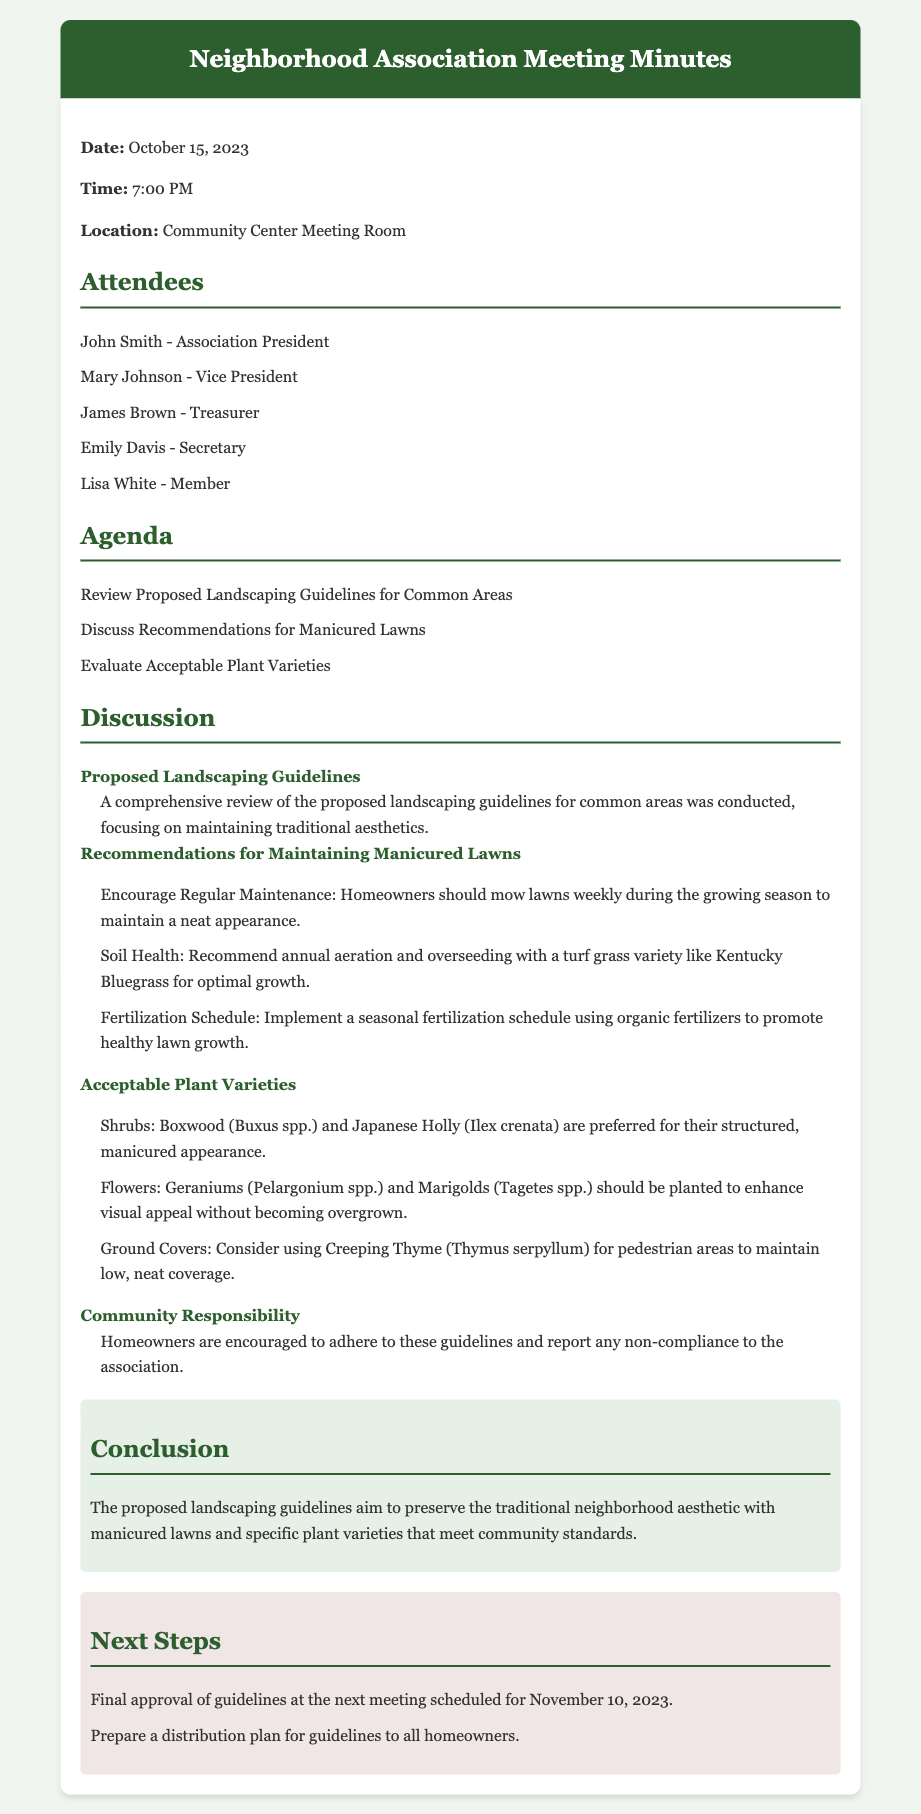What is the date of the meeting? The date of the meeting is explicitly stated in the document as October 15, 2023.
Answer: October 15, 2023 Who is the Vice President? The document lists the attendees, with Mary Johnson identified as the Vice President.
Answer: Mary Johnson What is one recommended action for maintaining lawns? The discussion section includes specific recommendations, one of which is to mow lawns weekly during the growing season.
Answer: Mow lawns weekly Which shrub variety is preferred? The acceptable plant varieties mention Boxwood as a preferred shrub for its manicured appearance.
Answer: Boxwood What will be discussed at the next meeting? The next meeting's agenda includes the final approval of the guidelines, which is explicitly mentioned in the next steps section.
Answer: Final approval of guidelines What type of fertilizer is recommended? The recommendations include implementing a seasonal fertilization schedule using organic fertilizers.
Answer: Organic fertilizers What is the location of the meeting? The document specifies the location where the meeting was held: Community Center Meeting Room.
Answer: Community Center Meeting Room What is the purpose of the proposed landscaping guidelines? The conclusion states that the purpose is to preserve traditional neighborhood aesthetics.
Answer: Preserve the traditional neighborhood aesthetic What is the next meeting date? The document includes a specific date for the next meeting, which is November 10, 2023.
Answer: November 10, 2023 